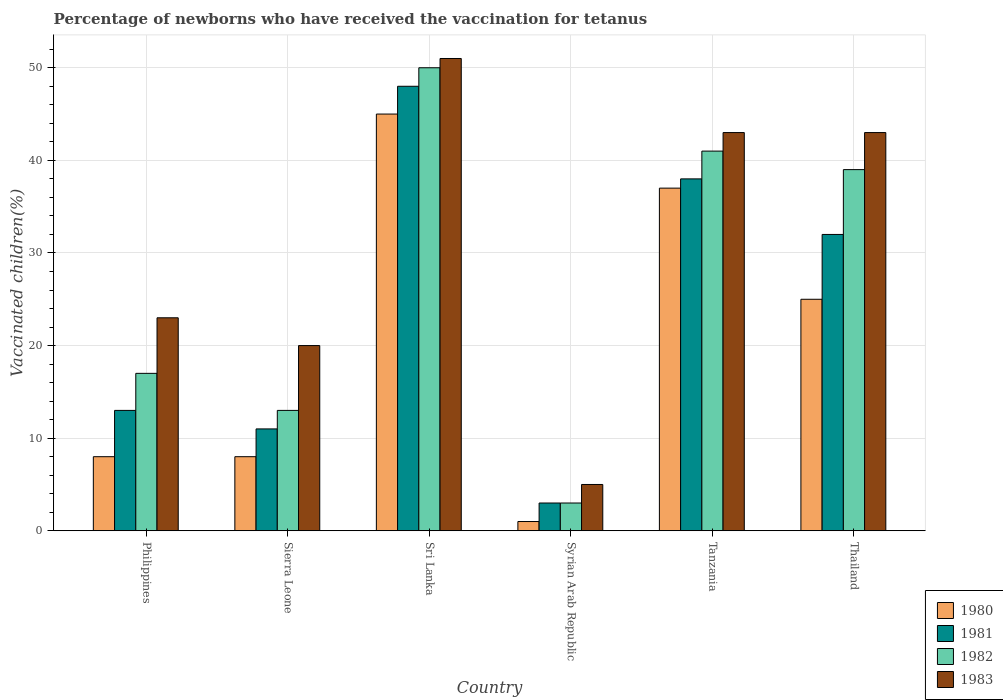Are the number of bars per tick equal to the number of legend labels?
Provide a succinct answer. Yes. Are the number of bars on each tick of the X-axis equal?
Provide a short and direct response. Yes. How many bars are there on the 4th tick from the left?
Offer a very short reply. 4. In how many cases, is the number of bars for a given country not equal to the number of legend labels?
Offer a terse response. 0. What is the percentage of vaccinated children in 1983 in Thailand?
Provide a short and direct response. 43. Across all countries, what is the minimum percentage of vaccinated children in 1983?
Offer a very short reply. 5. In which country was the percentage of vaccinated children in 1981 maximum?
Provide a succinct answer. Sri Lanka. In which country was the percentage of vaccinated children in 1980 minimum?
Your response must be concise. Syrian Arab Republic. What is the total percentage of vaccinated children in 1982 in the graph?
Ensure brevity in your answer.  163. What is the difference between the percentage of vaccinated children in 1980 in Sri Lanka and that in Syrian Arab Republic?
Your response must be concise. 44. What is the difference between the percentage of vaccinated children in 1982 in Sierra Leone and the percentage of vaccinated children in 1980 in Thailand?
Give a very brief answer. -12. What is the average percentage of vaccinated children in 1982 per country?
Make the answer very short. 27.17. In how many countries, is the percentage of vaccinated children in 1981 greater than 2 %?
Provide a succinct answer. 6. What is the ratio of the percentage of vaccinated children in 1981 in Syrian Arab Republic to that in Tanzania?
Your answer should be compact. 0.08. Is the percentage of vaccinated children in 1983 in Tanzania less than that in Thailand?
Give a very brief answer. No. What is the difference between the highest and the second highest percentage of vaccinated children in 1982?
Your answer should be very brief. -9. What does the 2nd bar from the left in Tanzania represents?
Make the answer very short. 1981. How many countries are there in the graph?
Provide a succinct answer. 6. What is the difference between two consecutive major ticks on the Y-axis?
Ensure brevity in your answer.  10. Are the values on the major ticks of Y-axis written in scientific E-notation?
Your response must be concise. No. Does the graph contain any zero values?
Your response must be concise. No. Does the graph contain grids?
Your response must be concise. Yes. How are the legend labels stacked?
Ensure brevity in your answer.  Vertical. What is the title of the graph?
Make the answer very short. Percentage of newborns who have received the vaccination for tetanus. Does "1977" appear as one of the legend labels in the graph?
Offer a terse response. No. What is the label or title of the X-axis?
Ensure brevity in your answer.  Country. What is the label or title of the Y-axis?
Keep it short and to the point. Vaccinated children(%). What is the Vaccinated children(%) in 1980 in Philippines?
Make the answer very short. 8. What is the Vaccinated children(%) in 1981 in Philippines?
Your answer should be very brief. 13. What is the Vaccinated children(%) in 1982 in Philippines?
Provide a succinct answer. 17. What is the Vaccinated children(%) in 1983 in Philippines?
Ensure brevity in your answer.  23. What is the Vaccinated children(%) in 1980 in Sri Lanka?
Offer a terse response. 45. What is the Vaccinated children(%) of 1982 in Sri Lanka?
Ensure brevity in your answer.  50. What is the Vaccinated children(%) in 1983 in Syrian Arab Republic?
Keep it short and to the point. 5. What is the Vaccinated children(%) of 1980 in Tanzania?
Your answer should be very brief. 37. What is the Vaccinated children(%) of 1982 in Tanzania?
Offer a very short reply. 41. Across all countries, what is the maximum Vaccinated children(%) of 1981?
Give a very brief answer. 48. Across all countries, what is the maximum Vaccinated children(%) of 1982?
Offer a terse response. 50. Across all countries, what is the minimum Vaccinated children(%) in 1980?
Give a very brief answer. 1. Across all countries, what is the minimum Vaccinated children(%) in 1981?
Offer a very short reply. 3. Across all countries, what is the minimum Vaccinated children(%) in 1983?
Your answer should be compact. 5. What is the total Vaccinated children(%) in 1980 in the graph?
Your answer should be compact. 124. What is the total Vaccinated children(%) of 1981 in the graph?
Keep it short and to the point. 145. What is the total Vaccinated children(%) in 1982 in the graph?
Provide a short and direct response. 163. What is the total Vaccinated children(%) of 1983 in the graph?
Keep it short and to the point. 185. What is the difference between the Vaccinated children(%) of 1983 in Philippines and that in Sierra Leone?
Give a very brief answer. 3. What is the difference between the Vaccinated children(%) in 1980 in Philippines and that in Sri Lanka?
Make the answer very short. -37. What is the difference between the Vaccinated children(%) of 1981 in Philippines and that in Sri Lanka?
Offer a very short reply. -35. What is the difference between the Vaccinated children(%) of 1982 in Philippines and that in Sri Lanka?
Make the answer very short. -33. What is the difference between the Vaccinated children(%) of 1982 in Philippines and that in Syrian Arab Republic?
Keep it short and to the point. 14. What is the difference between the Vaccinated children(%) of 1980 in Philippines and that in Tanzania?
Give a very brief answer. -29. What is the difference between the Vaccinated children(%) in 1981 in Philippines and that in Tanzania?
Make the answer very short. -25. What is the difference between the Vaccinated children(%) in 1983 in Philippines and that in Tanzania?
Your answer should be compact. -20. What is the difference between the Vaccinated children(%) of 1980 in Philippines and that in Thailand?
Give a very brief answer. -17. What is the difference between the Vaccinated children(%) in 1982 in Philippines and that in Thailand?
Keep it short and to the point. -22. What is the difference between the Vaccinated children(%) of 1980 in Sierra Leone and that in Sri Lanka?
Provide a short and direct response. -37. What is the difference between the Vaccinated children(%) in 1981 in Sierra Leone and that in Sri Lanka?
Your response must be concise. -37. What is the difference between the Vaccinated children(%) in 1982 in Sierra Leone and that in Sri Lanka?
Your answer should be very brief. -37. What is the difference between the Vaccinated children(%) of 1983 in Sierra Leone and that in Sri Lanka?
Keep it short and to the point. -31. What is the difference between the Vaccinated children(%) of 1981 in Sierra Leone and that in Syrian Arab Republic?
Offer a very short reply. 8. What is the difference between the Vaccinated children(%) of 1982 in Sierra Leone and that in Thailand?
Your response must be concise. -26. What is the difference between the Vaccinated children(%) of 1980 in Sri Lanka and that in Syrian Arab Republic?
Provide a short and direct response. 44. What is the difference between the Vaccinated children(%) in 1981 in Sri Lanka and that in Syrian Arab Republic?
Provide a short and direct response. 45. What is the difference between the Vaccinated children(%) in 1980 in Sri Lanka and that in Tanzania?
Your answer should be compact. 8. What is the difference between the Vaccinated children(%) of 1983 in Sri Lanka and that in Thailand?
Offer a very short reply. 8. What is the difference between the Vaccinated children(%) in 1980 in Syrian Arab Republic and that in Tanzania?
Provide a succinct answer. -36. What is the difference between the Vaccinated children(%) of 1981 in Syrian Arab Republic and that in Tanzania?
Your response must be concise. -35. What is the difference between the Vaccinated children(%) in 1982 in Syrian Arab Republic and that in Tanzania?
Your response must be concise. -38. What is the difference between the Vaccinated children(%) of 1983 in Syrian Arab Republic and that in Tanzania?
Provide a short and direct response. -38. What is the difference between the Vaccinated children(%) in 1982 in Syrian Arab Republic and that in Thailand?
Your answer should be compact. -36. What is the difference between the Vaccinated children(%) in 1983 in Syrian Arab Republic and that in Thailand?
Make the answer very short. -38. What is the difference between the Vaccinated children(%) of 1980 in Tanzania and that in Thailand?
Your answer should be very brief. 12. What is the difference between the Vaccinated children(%) in 1980 in Philippines and the Vaccinated children(%) in 1981 in Sierra Leone?
Give a very brief answer. -3. What is the difference between the Vaccinated children(%) in 1980 in Philippines and the Vaccinated children(%) in 1982 in Sierra Leone?
Your answer should be compact. -5. What is the difference between the Vaccinated children(%) of 1980 in Philippines and the Vaccinated children(%) of 1983 in Sierra Leone?
Give a very brief answer. -12. What is the difference between the Vaccinated children(%) of 1982 in Philippines and the Vaccinated children(%) of 1983 in Sierra Leone?
Your answer should be compact. -3. What is the difference between the Vaccinated children(%) of 1980 in Philippines and the Vaccinated children(%) of 1981 in Sri Lanka?
Give a very brief answer. -40. What is the difference between the Vaccinated children(%) in 1980 in Philippines and the Vaccinated children(%) in 1982 in Sri Lanka?
Offer a very short reply. -42. What is the difference between the Vaccinated children(%) in 1980 in Philippines and the Vaccinated children(%) in 1983 in Sri Lanka?
Provide a succinct answer. -43. What is the difference between the Vaccinated children(%) in 1981 in Philippines and the Vaccinated children(%) in 1982 in Sri Lanka?
Your answer should be compact. -37. What is the difference between the Vaccinated children(%) in 1981 in Philippines and the Vaccinated children(%) in 1983 in Sri Lanka?
Your answer should be compact. -38. What is the difference between the Vaccinated children(%) of 1982 in Philippines and the Vaccinated children(%) of 1983 in Sri Lanka?
Your response must be concise. -34. What is the difference between the Vaccinated children(%) in 1980 in Philippines and the Vaccinated children(%) in 1982 in Syrian Arab Republic?
Your answer should be very brief. 5. What is the difference between the Vaccinated children(%) of 1981 in Philippines and the Vaccinated children(%) of 1982 in Syrian Arab Republic?
Your response must be concise. 10. What is the difference between the Vaccinated children(%) in 1981 in Philippines and the Vaccinated children(%) in 1983 in Syrian Arab Republic?
Provide a succinct answer. 8. What is the difference between the Vaccinated children(%) of 1980 in Philippines and the Vaccinated children(%) of 1982 in Tanzania?
Keep it short and to the point. -33. What is the difference between the Vaccinated children(%) in 1980 in Philippines and the Vaccinated children(%) in 1983 in Tanzania?
Offer a very short reply. -35. What is the difference between the Vaccinated children(%) of 1981 in Philippines and the Vaccinated children(%) of 1982 in Tanzania?
Make the answer very short. -28. What is the difference between the Vaccinated children(%) of 1980 in Philippines and the Vaccinated children(%) of 1981 in Thailand?
Your response must be concise. -24. What is the difference between the Vaccinated children(%) of 1980 in Philippines and the Vaccinated children(%) of 1982 in Thailand?
Offer a very short reply. -31. What is the difference between the Vaccinated children(%) of 1980 in Philippines and the Vaccinated children(%) of 1983 in Thailand?
Give a very brief answer. -35. What is the difference between the Vaccinated children(%) in 1982 in Philippines and the Vaccinated children(%) in 1983 in Thailand?
Your answer should be compact. -26. What is the difference between the Vaccinated children(%) of 1980 in Sierra Leone and the Vaccinated children(%) of 1981 in Sri Lanka?
Ensure brevity in your answer.  -40. What is the difference between the Vaccinated children(%) in 1980 in Sierra Leone and the Vaccinated children(%) in 1982 in Sri Lanka?
Offer a very short reply. -42. What is the difference between the Vaccinated children(%) in 1980 in Sierra Leone and the Vaccinated children(%) in 1983 in Sri Lanka?
Your answer should be very brief. -43. What is the difference between the Vaccinated children(%) of 1981 in Sierra Leone and the Vaccinated children(%) of 1982 in Sri Lanka?
Provide a succinct answer. -39. What is the difference between the Vaccinated children(%) of 1981 in Sierra Leone and the Vaccinated children(%) of 1983 in Sri Lanka?
Offer a very short reply. -40. What is the difference between the Vaccinated children(%) in 1982 in Sierra Leone and the Vaccinated children(%) in 1983 in Sri Lanka?
Offer a very short reply. -38. What is the difference between the Vaccinated children(%) in 1980 in Sierra Leone and the Vaccinated children(%) in 1983 in Syrian Arab Republic?
Your answer should be compact. 3. What is the difference between the Vaccinated children(%) in 1981 in Sierra Leone and the Vaccinated children(%) in 1983 in Syrian Arab Republic?
Keep it short and to the point. 6. What is the difference between the Vaccinated children(%) in 1980 in Sierra Leone and the Vaccinated children(%) in 1981 in Tanzania?
Make the answer very short. -30. What is the difference between the Vaccinated children(%) of 1980 in Sierra Leone and the Vaccinated children(%) of 1982 in Tanzania?
Your response must be concise. -33. What is the difference between the Vaccinated children(%) in 1980 in Sierra Leone and the Vaccinated children(%) in 1983 in Tanzania?
Provide a short and direct response. -35. What is the difference between the Vaccinated children(%) of 1981 in Sierra Leone and the Vaccinated children(%) of 1983 in Tanzania?
Provide a short and direct response. -32. What is the difference between the Vaccinated children(%) in 1982 in Sierra Leone and the Vaccinated children(%) in 1983 in Tanzania?
Your answer should be compact. -30. What is the difference between the Vaccinated children(%) in 1980 in Sierra Leone and the Vaccinated children(%) in 1981 in Thailand?
Give a very brief answer. -24. What is the difference between the Vaccinated children(%) in 1980 in Sierra Leone and the Vaccinated children(%) in 1982 in Thailand?
Your answer should be compact. -31. What is the difference between the Vaccinated children(%) of 1980 in Sierra Leone and the Vaccinated children(%) of 1983 in Thailand?
Offer a terse response. -35. What is the difference between the Vaccinated children(%) of 1981 in Sierra Leone and the Vaccinated children(%) of 1982 in Thailand?
Give a very brief answer. -28. What is the difference between the Vaccinated children(%) of 1981 in Sierra Leone and the Vaccinated children(%) of 1983 in Thailand?
Keep it short and to the point. -32. What is the difference between the Vaccinated children(%) in 1982 in Sierra Leone and the Vaccinated children(%) in 1983 in Thailand?
Your answer should be very brief. -30. What is the difference between the Vaccinated children(%) in 1980 in Sri Lanka and the Vaccinated children(%) in 1981 in Syrian Arab Republic?
Offer a terse response. 42. What is the difference between the Vaccinated children(%) of 1980 in Sri Lanka and the Vaccinated children(%) of 1982 in Syrian Arab Republic?
Make the answer very short. 42. What is the difference between the Vaccinated children(%) of 1980 in Sri Lanka and the Vaccinated children(%) of 1983 in Syrian Arab Republic?
Your answer should be very brief. 40. What is the difference between the Vaccinated children(%) in 1980 in Sri Lanka and the Vaccinated children(%) in 1981 in Tanzania?
Give a very brief answer. 7. What is the difference between the Vaccinated children(%) in 1980 in Sri Lanka and the Vaccinated children(%) in 1983 in Tanzania?
Offer a terse response. 2. What is the difference between the Vaccinated children(%) of 1981 in Sri Lanka and the Vaccinated children(%) of 1982 in Tanzania?
Provide a short and direct response. 7. What is the difference between the Vaccinated children(%) in 1980 in Sri Lanka and the Vaccinated children(%) in 1981 in Thailand?
Keep it short and to the point. 13. What is the difference between the Vaccinated children(%) of 1981 in Sri Lanka and the Vaccinated children(%) of 1982 in Thailand?
Provide a succinct answer. 9. What is the difference between the Vaccinated children(%) in 1980 in Syrian Arab Republic and the Vaccinated children(%) in 1981 in Tanzania?
Your answer should be very brief. -37. What is the difference between the Vaccinated children(%) in 1980 in Syrian Arab Republic and the Vaccinated children(%) in 1983 in Tanzania?
Give a very brief answer. -42. What is the difference between the Vaccinated children(%) of 1981 in Syrian Arab Republic and the Vaccinated children(%) of 1982 in Tanzania?
Your answer should be very brief. -38. What is the difference between the Vaccinated children(%) of 1982 in Syrian Arab Republic and the Vaccinated children(%) of 1983 in Tanzania?
Offer a very short reply. -40. What is the difference between the Vaccinated children(%) in 1980 in Syrian Arab Republic and the Vaccinated children(%) in 1981 in Thailand?
Your answer should be compact. -31. What is the difference between the Vaccinated children(%) of 1980 in Syrian Arab Republic and the Vaccinated children(%) of 1982 in Thailand?
Your answer should be compact. -38. What is the difference between the Vaccinated children(%) of 1980 in Syrian Arab Republic and the Vaccinated children(%) of 1983 in Thailand?
Your answer should be compact. -42. What is the difference between the Vaccinated children(%) of 1981 in Syrian Arab Republic and the Vaccinated children(%) of 1982 in Thailand?
Your response must be concise. -36. What is the difference between the Vaccinated children(%) in 1981 in Syrian Arab Republic and the Vaccinated children(%) in 1983 in Thailand?
Give a very brief answer. -40. What is the difference between the Vaccinated children(%) of 1982 in Syrian Arab Republic and the Vaccinated children(%) of 1983 in Thailand?
Provide a succinct answer. -40. What is the difference between the Vaccinated children(%) of 1980 in Tanzania and the Vaccinated children(%) of 1981 in Thailand?
Offer a very short reply. 5. What is the difference between the Vaccinated children(%) of 1981 in Tanzania and the Vaccinated children(%) of 1982 in Thailand?
Ensure brevity in your answer.  -1. What is the difference between the Vaccinated children(%) in 1982 in Tanzania and the Vaccinated children(%) in 1983 in Thailand?
Make the answer very short. -2. What is the average Vaccinated children(%) in 1980 per country?
Your answer should be very brief. 20.67. What is the average Vaccinated children(%) of 1981 per country?
Make the answer very short. 24.17. What is the average Vaccinated children(%) of 1982 per country?
Offer a very short reply. 27.17. What is the average Vaccinated children(%) in 1983 per country?
Your answer should be compact. 30.83. What is the difference between the Vaccinated children(%) in 1980 and Vaccinated children(%) in 1981 in Philippines?
Your answer should be very brief. -5. What is the difference between the Vaccinated children(%) of 1980 and Vaccinated children(%) of 1982 in Philippines?
Ensure brevity in your answer.  -9. What is the difference between the Vaccinated children(%) of 1980 and Vaccinated children(%) of 1983 in Philippines?
Provide a short and direct response. -15. What is the difference between the Vaccinated children(%) in 1981 and Vaccinated children(%) in 1983 in Philippines?
Make the answer very short. -10. What is the difference between the Vaccinated children(%) of 1982 and Vaccinated children(%) of 1983 in Philippines?
Ensure brevity in your answer.  -6. What is the difference between the Vaccinated children(%) in 1980 and Vaccinated children(%) in 1981 in Sierra Leone?
Ensure brevity in your answer.  -3. What is the difference between the Vaccinated children(%) in 1980 and Vaccinated children(%) in 1982 in Sierra Leone?
Offer a very short reply. -5. What is the difference between the Vaccinated children(%) of 1981 and Vaccinated children(%) of 1983 in Sierra Leone?
Ensure brevity in your answer.  -9. What is the difference between the Vaccinated children(%) of 1982 and Vaccinated children(%) of 1983 in Sierra Leone?
Your answer should be very brief. -7. What is the difference between the Vaccinated children(%) in 1981 and Vaccinated children(%) in 1982 in Sri Lanka?
Give a very brief answer. -2. What is the difference between the Vaccinated children(%) in 1981 and Vaccinated children(%) in 1983 in Sri Lanka?
Keep it short and to the point. -3. What is the difference between the Vaccinated children(%) in 1982 and Vaccinated children(%) in 1983 in Sri Lanka?
Keep it short and to the point. -1. What is the difference between the Vaccinated children(%) of 1980 and Vaccinated children(%) of 1982 in Syrian Arab Republic?
Give a very brief answer. -2. What is the difference between the Vaccinated children(%) of 1981 and Vaccinated children(%) of 1983 in Syrian Arab Republic?
Your answer should be compact. -2. What is the difference between the Vaccinated children(%) in 1982 and Vaccinated children(%) in 1983 in Syrian Arab Republic?
Offer a very short reply. -2. What is the difference between the Vaccinated children(%) in 1980 and Vaccinated children(%) in 1981 in Tanzania?
Provide a succinct answer. -1. What is the difference between the Vaccinated children(%) of 1980 and Vaccinated children(%) of 1982 in Tanzania?
Keep it short and to the point. -4. What is the difference between the Vaccinated children(%) in 1981 and Vaccinated children(%) in 1983 in Tanzania?
Keep it short and to the point. -5. What is the difference between the Vaccinated children(%) of 1980 and Vaccinated children(%) of 1981 in Thailand?
Offer a terse response. -7. What is the difference between the Vaccinated children(%) in 1981 and Vaccinated children(%) in 1982 in Thailand?
Keep it short and to the point. -7. What is the difference between the Vaccinated children(%) in 1981 and Vaccinated children(%) in 1983 in Thailand?
Make the answer very short. -11. What is the difference between the Vaccinated children(%) of 1982 and Vaccinated children(%) of 1983 in Thailand?
Make the answer very short. -4. What is the ratio of the Vaccinated children(%) in 1981 in Philippines to that in Sierra Leone?
Your response must be concise. 1.18. What is the ratio of the Vaccinated children(%) of 1982 in Philippines to that in Sierra Leone?
Make the answer very short. 1.31. What is the ratio of the Vaccinated children(%) of 1983 in Philippines to that in Sierra Leone?
Provide a short and direct response. 1.15. What is the ratio of the Vaccinated children(%) of 1980 in Philippines to that in Sri Lanka?
Provide a short and direct response. 0.18. What is the ratio of the Vaccinated children(%) of 1981 in Philippines to that in Sri Lanka?
Your answer should be compact. 0.27. What is the ratio of the Vaccinated children(%) of 1982 in Philippines to that in Sri Lanka?
Provide a short and direct response. 0.34. What is the ratio of the Vaccinated children(%) in 1983 in Philippines to that in Sri Lanka?
Give a very brief answer. 0.45. What is the ratio of the Vaccinated children(%) of 1981 in Philippines to that in Syrian Arab Republic?
Give a very brief answer. 4.33. What is the ratio of the Vaccinated children(%) in 1982 in Philippines to that in Syrian Arab Republic?
Make the answer very short. 5.67. What is the ratio of the Vaccinated children(%) in 1980 in Philippines to that in Tanzania?
Your answer should be compact. 0.22. What is the ratio of the Vaccinated children(%) in 1981 in Philippines to that in Tanzania?
Provide a succinct answer. 0.34. What is the ratio of the Vaccinated children(%) of 1982 in Philippines to that in Tanzania?
Your answer should be very brief. 0.41. What is the ratio of the Vaccinated children(%) of 1983 in Philippines to that in Tanzania?
Keep it short and to the point. 0.53. What is the ratio of the Vaccinated children(%) in 1980 in Philippines to that in Thailand?
Offer a very short reply. 0.32. What is the ratio of the Vaccinated children(%) in 1981 in Philippines to that in Thailand?
Offer a terse response. 0.41. What is the ratio of the Vaccinated children(%) of 1982 in Philippines to that in Thailand?
Your answer should be compact. 0.44. What is the ratio of the Vaccinated children(%) in 1983 in Philippines to that in Thailand?
Offer a very short reply. 0.53. What is the ratio of the Vaccinated children(%) in 1980 in Sierra Leone to that in Sri Lanka?
Provide a succinct answer. 0.18. What is the ratio of the Vaccinated children(%) of 1981 in Sierra Leone to that in Sri Lanka?
Give a very brief answer. 0.23. What is the ratio of the Vaccinated children(%) of 1982 in Sierra Leone to that in Sri Lanka?
Offer a very short reply. 0.26. What is the ratio of the Vaccinated children(%) of 1983 in Sierra Leone to that in Sri Lanka?
Provide a short and direct response. 0.39. What is the ratio of the Vaccinated children(%) in 1981 in Sierra Leone to that in Syrian Arab Republic?
Offer a terse response. 3.67. What is the ratio of the Vaccinated children(%) of 1982 in Sierra Leone to that in Syrian Arab Republic?
Ensure brevity in your answer.  4.33. What is the ratio of the Vaccinated children(%) of 1983 in Sierra Leone to that in Syrian Arab Republic?
Your answer should be very brief. 4. What is the ratio of the Vaccinated children(%) in 1980 in Sierra Leone to that in Tanzania?
Give a very brief answer. 0.22. What is the ratio of the Vaccinated children(%) of 1981 in Sierra Leone to that in Tanzania?
Ensure brevity in your answer.  0.29. What is the ratio of the Vaccinated children(%) of 1982 in Sierra Leone to that in Tanzania?
Your response must be concise. 0.32. What is the ratio of the Vaccinated children(%) in 1983 in Sierra Leone to that in Tanzania?
Provide a short and direct response. 0.47. What is the ratio of the Vaccinated children(%) in 1980 in Sierra Leone to that in Thailand?
Provide a succinct answer. 0.32. What is the ratio of the Vaccinated children(%) in 1981 in Sierra Leone to that in Thailand?
Give a very brief answer. 0.34. What is the ratio of the Vaccinated children(%) of 1982 in Sierra Leone to that in Thailand?
Ensure brevity in your answer.  0.33. What is the ratio of the Vaccinated children(%) in 1983 in Sierra Leone to that in Thailand?
Ensure brevity in your answer.  0.47. What is the ratio of the Vaccinated children(%) in 1981 in Sri Lanka to that in Syrian Arab Republic?
Provide a short and direct response. 16. What is the ratio of the Vaccinated children(%) in 1982 in Sri Lanka to that in Syrian Arab Republic?
Offer a terse response. 16.67. What is the ratio of the Vaccinated children(%) in 1980 in Sri Lanka to that in Tanzania?
Make the answer very short. 1.22. What is the ratio of the Vaccinated children(%) of 1981 in Sri Lanka to that in Tanzania?
Offer a terse response. 1.26. What is the ratio of the Vaccinated children(%) of 1982 in Sri Lanka to that in Tanzania?
Your answer should be very brief. 1.22. What is the ratio of the Vaccinated children(%) of 1983 in Sri Lanka to that in Tanzania?
Your answer should be compact. 1.19. What is the ratio of the Vaccinated children(%) in 1980 in Sri Lanka to that in Thailand?
Ensure brevity in your answer.  1.8. What is the ratio of the Vaccinated children(%) of 1981 in Sri Lanka to that in Thailand?
Ensure brevity in your answer.  1.5. What is the ratio of the Vaccinated children(%) in 1982 in Sri Lanka to that in Thailand?
Keep it short and to the point. 1.28. What is the ratio of the Vaccinated children(%) in 1983 in Sri Lanka to that in Thailand?
Your answer should be very brief. 1.19. What is the ratio of the Vaccinated children(%) in 1980 in Syrian Arab Republic to that in Tanzania?
Provide a succinct answer. 0.03. What is the ratio of the Vaccinated children(%) in 1981 in Syrian Arab Republic to that in Tanzania?
Keep it short and to the point. 0.08. What is the ratio of the Vaccinated children(%) of 1982 in Syrian Arab Republic to that in Tanzania?
Your answer should be compact. 0.07. What is the ratio of the Vaccinated children(%) of 1983 in Syrian Arab Republic to that in Tanzania?
Your answer should be very brief. 0.12. What is the ratio of the Vaccinated children(%) of 1980 in Syrian Arab Republic to that in Thailand?
Your answer should be compact. 0.04. What is the ratio of the Vaccinated children(%) in 1981 in Syrian Arab Republic to that in Thailand?
Your answer should be very brief. 0.09. What is the ratio of the Vaccinated children(%) in 1982 in Syrian Arab Republic to that in Thailand?
Make the answer very short. 0.08. What is the ratio of the Vaccinated children(%) of 1983 in Syrian Arab Republic to that in Thailand?
Your response must be concise. 0.12. What is the ratio of the Vaccinated children(%) of 1980 in Tanzania to that in Thailand?
Your answer should be compact. 1.48. What is the ratio of the Vaccinated children(%) in 1981 in Tanzania to that in Thailand?
Offer a very short reply. 1.19. What is the ratio of the Vaccinated children(%) in 1982 in Tanzania to that in Thailand?
Offer a very short reply. 1.05. What is the ratio of the Vaccinated children(%) of 1983 in Tanzania to that in Thailand?
Provide a succinct answer. 1. What is the difference between the highest and the second highest Vaccinated children(%) in 1980?
Keep it short and to the point. 8. What is the difference between the highest and the second highest Vaccinated children(%) in 1981?
Give a very brief answer. 10. What is the difference between the highest and the second highest Vaccinated children(%) of 1982?
Give a very brief answer. 9. What is the difference between the highest and the second highest Vaccinated children(%) in 1983?
Your response must be concise. 8. What is the difference between the highest and the lowest Vaccinated children(%) of 1980?
Make the answer very short. 44. 